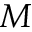Convert formula to latex. <formula><loc_0><loc_0><loc_500><loc_500>M</formula> 